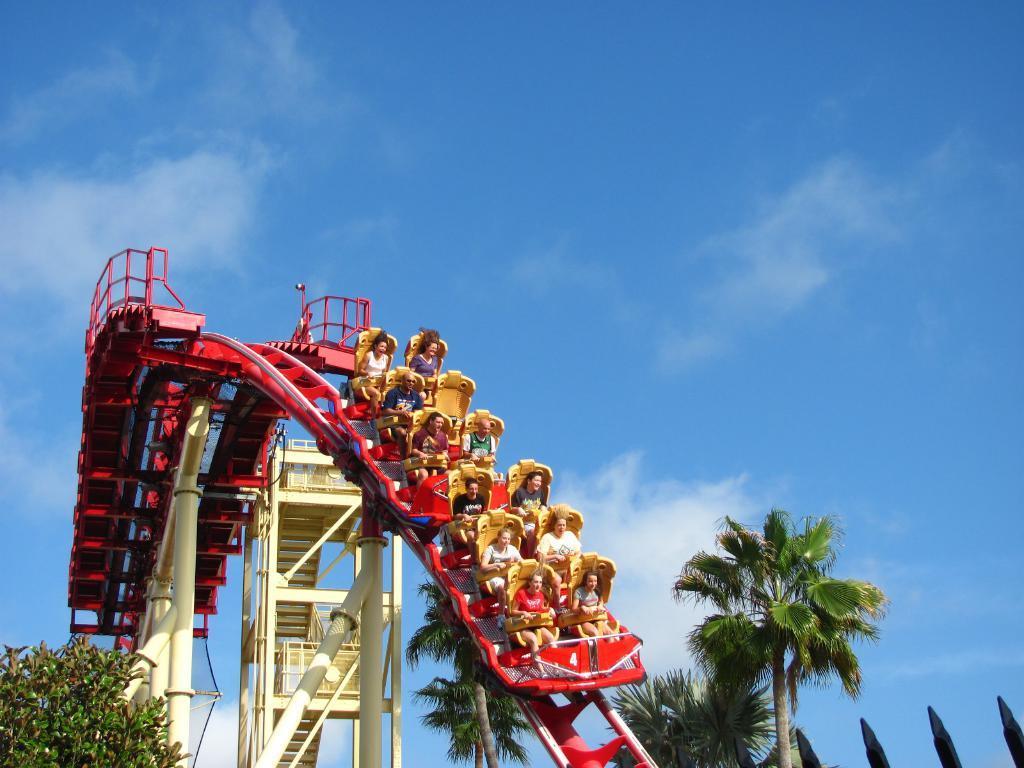How would you summarize this image in a sentence or two? Here we can see few persons on the amusing ride. There are trees and poles. In the background there is sky with clouds. 